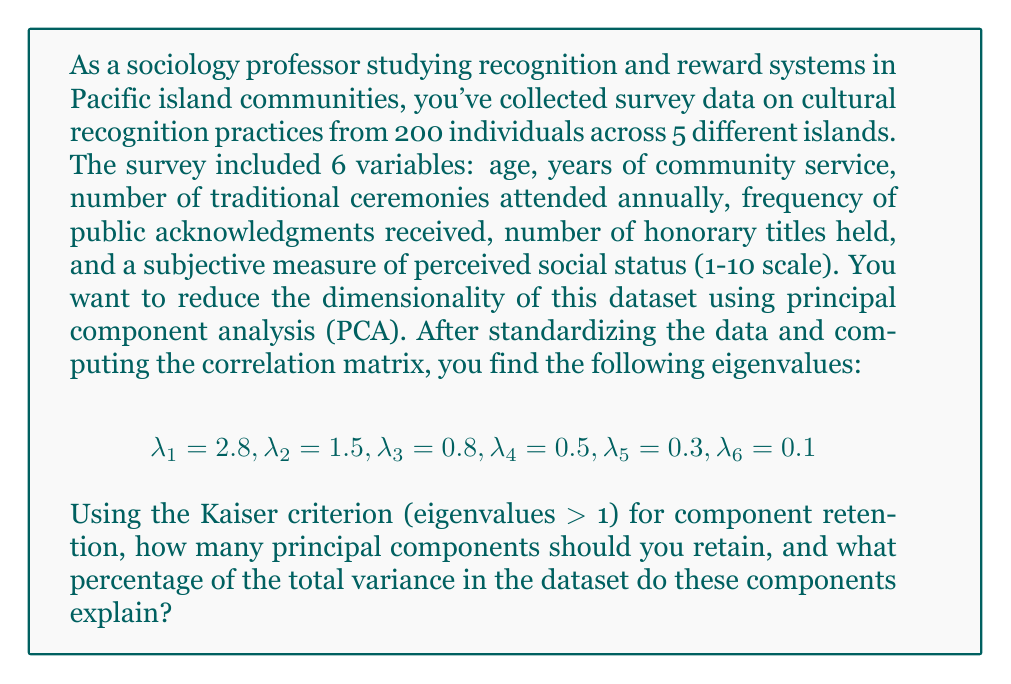Show me your answer to this math problem. To solve this problem, we need to follow these steps:

1. Identify the number of principal components to retain using the Kaiser criterion.
2. Calculate the total variance in the dataset.
3. Calculate the variance explained by the retained components.
4. Compute the percentage of total variance explained by the retained components.

Step 1: Kaiser criterion
The Kaiser criterion suggests retaining components with eigenvalues greater than 1. From the given eigenvalues:

$\lambda_1 = 2.8 > 1$
$\lambda_2 = 1.5 > 1$
$\lambda_3 = 0.8 < 1$

Therefore, we should retain 2 principal components.

Step 2: Total variance
In PCA, the total variance is equal to the number of variables when using standardized data. Here, we have 6 variables, so:

Total variance = 6

Alternatively, we can sum all eigenvalues:
$2.8 + 1.5 + 0.8 + 0.5 + 0.3 + 0.1 = 6$

Step 3: Variance explained by retained components
The variance explained by each component is equal to its eigenvalue. For the two retained components:

Variance explained = $\lambda_1 + \lambda_2 = 2.8 + 1.5 = 4.3$

Step 4: Percentage of total variance explained
To calculate the percentage of total variance explained, we divide the variance explained by the retained components by the total variance and multiply by 100:

Percentage of variance explained = $\frac{\text{Variance explained}}{\text{Total variance}} \times 100\%$

$= \frac{4.3}{6} \times 100\% = 71.67\%$
Answer: We should retain 2 principal components, which explain 71.67% of the total variance in the dataset. 